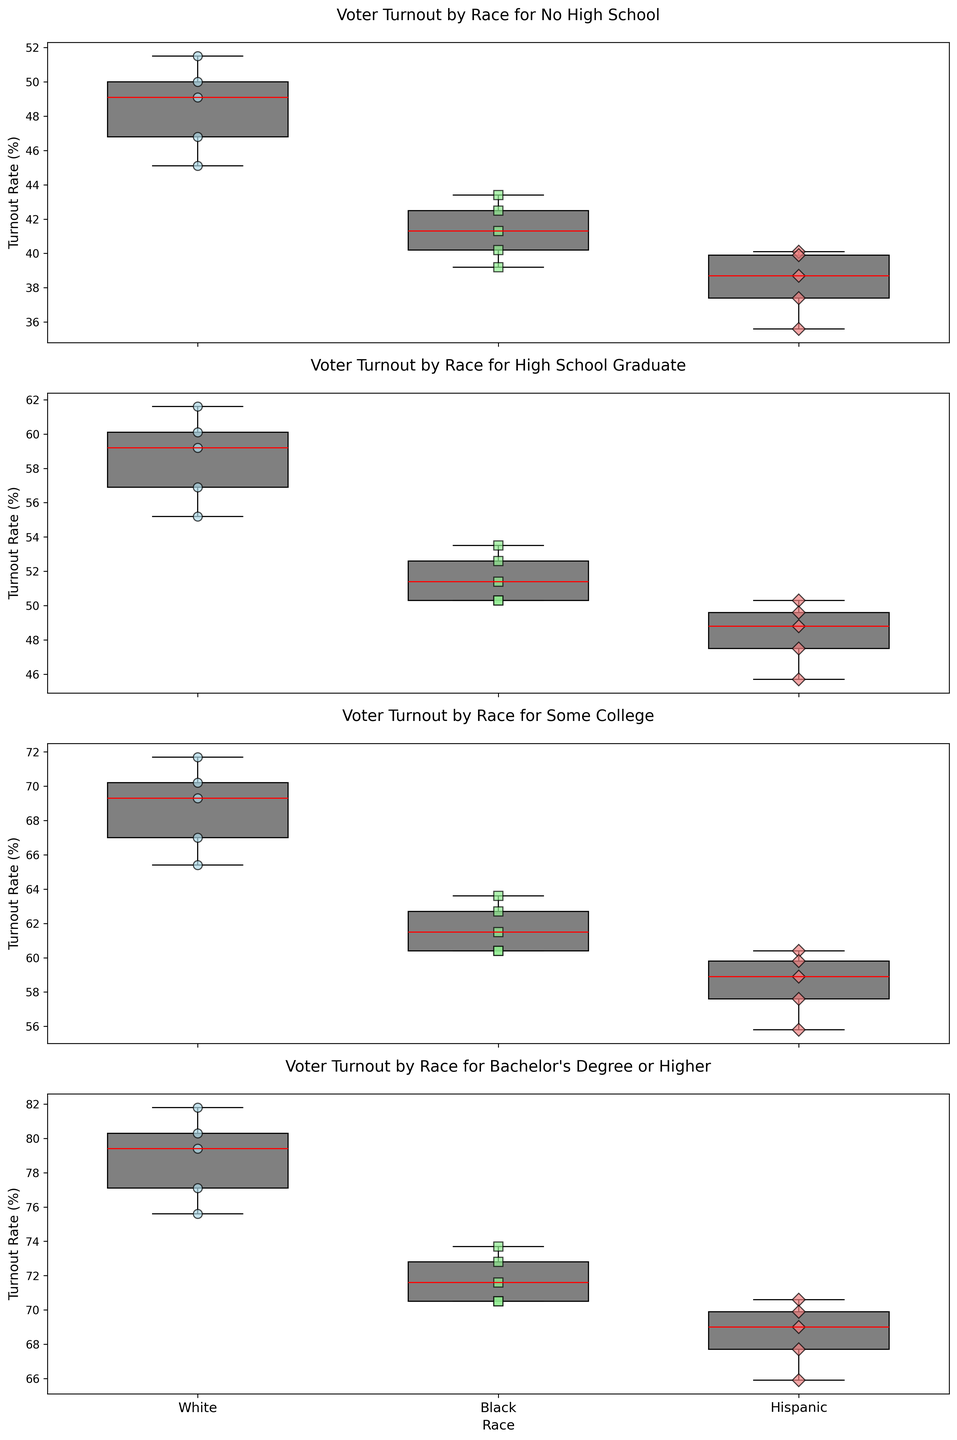Which race has the highest median turnout rate for voters with a Bachelor's Degree or Higher? To find this, look at the box plots for the "Bachelor's Degree or Higher" educational level. Check the median line (red line) across the races. The highest median line indicates the race with the highest turnout rate.
Answer: White Which state shows the smallest variance in voter turnout rates among Black voters with Some College education? Look at the width of the boxes (interquartile range) for Black voters under the "Some College" category in each state. The state with the narrowest box has the smallest variance.
Answer: Texas Which education level shows the most significant difference in median turnout rate between White and Hispanic voters? Compare the height difference of the median lines (red lines) between White and Hispanic voters across all educational levels. The greatest visual difference represents the most significant difference in median turnout rate.
Answer: Bachelor's Degree or Higher Are the turnout rates generally higher for White voters or Black voters across all education levels? Examine the median lines (red lines) for both White and Black voters across all educational levels. Determine if White voters' median lines are consistently higher than those of Black voters.
Answer: White voters Which race shows the most improvement in turnout rate when education increases from No High School to Bachelor's Degree or Higher? Look at the box plots for each race and compare the median lines (red lines) from "No High School" to "Bachelor's Degree or Higher". The race with the steepest increase in median turnout rate shows the most improvement.
Answer: White Is there a state where Hispanic voters' turnout rate with a High School Graduate education is higher than Black voters with Bachelor's Degree or Higher? Identify the box plots of Hispanic voters with "High School Graduate" and compare them with Black voters with "Bachelor's Degree or Higher" across states, looking at the median lines (red lines).
Answer: No What is the median turnout rate for Hispanic voters in Florida with Some College education? Locate the box plot for Hispanic voters in Florida under the "Some College" education level and identify the red line indicating the median turnout rate.
Answer: 59.8 In which education level do we observe the least difference in median turnout rate among all races? Compare the differences in the median lines (red lines) between races across all education levels. The smallest visual difference indicates the least median turnout rate difference.
Answer: High School Graduate What color is used to represent Black voters in the plots? Observe the color assigned to the marks and elements representing Black voters across the plots.
Answer: Light green 